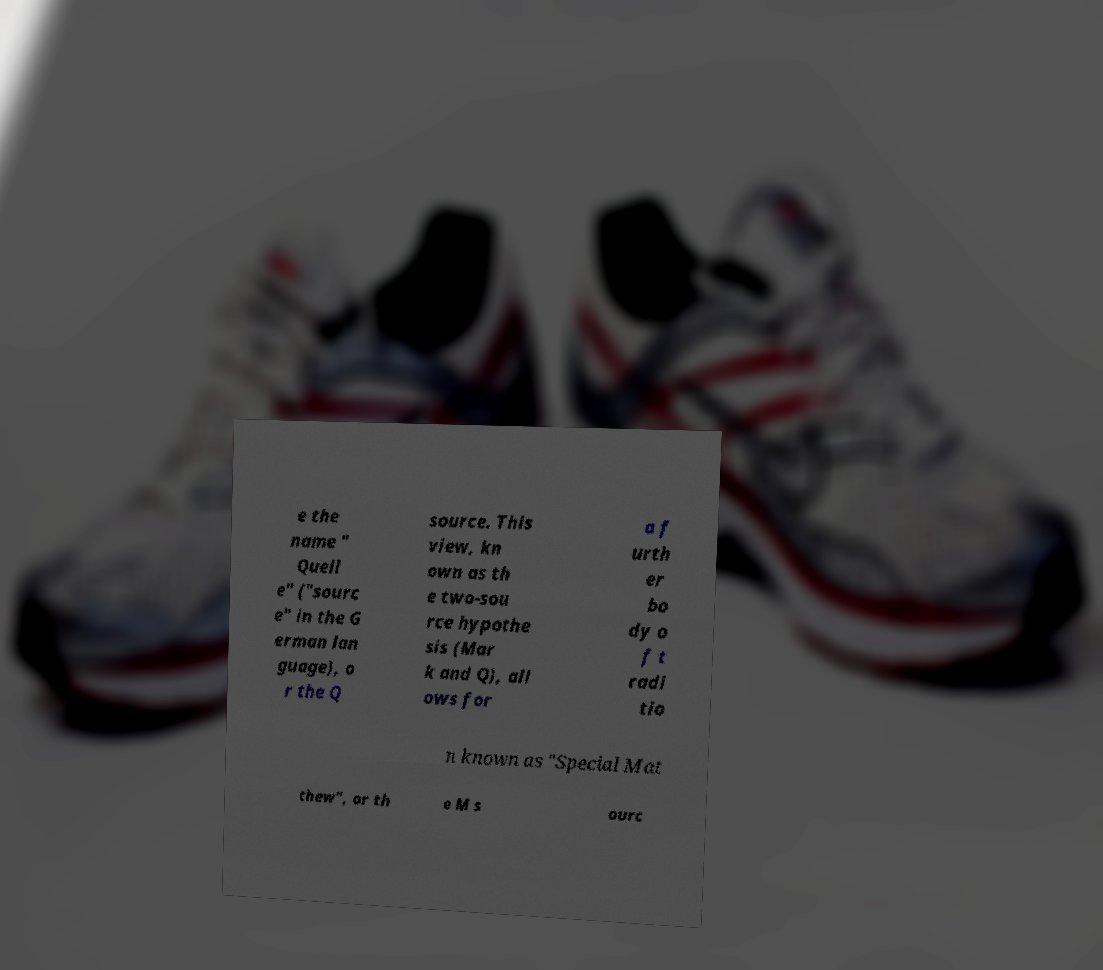I need the written content from this picture converted into text. Can you do that? e the name " Quell e" ("sourc e" in the G erman lan guage), o r the Q source. This view, kn own as th e two-sou rce hypothe sis (Mar k and Q), all ows for a f urth er bo dy o f t radi tio n known as "Special Mat thew", or th e M s ourc 